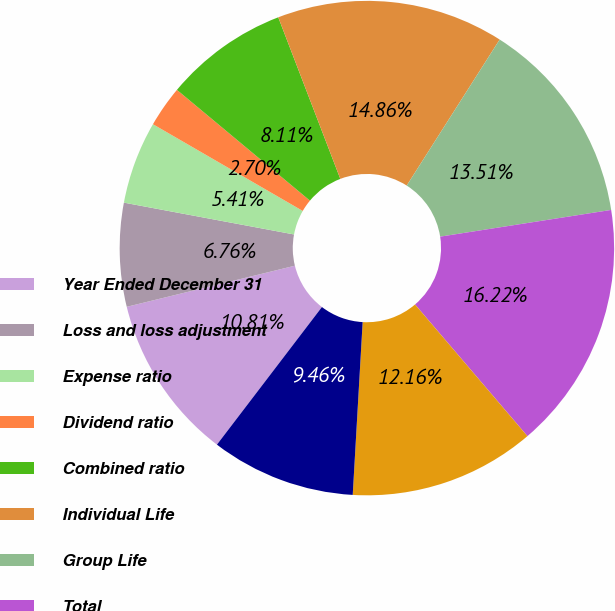<chart> <loc_0><loc_0><loc_500><loc_500><pie_chart><fcel>Year Ended December 31<fcel>Loss and loss adjustment<fcel>Expense ratio<fcel>Dividend ratio<fcel>Combined ratio<fcel>Individual Life<fcel>Group Life<fcel>Total<fcel>Property and casualty<fcel>Life and group companies'<nl><fcel>10.81%<fcel>6.76%<fcel>5.41%<fcel>2.7%<fcel>8.11%<fcel>14.86%<fcel>13.51%<fcel>16.22%<fcel>12.16%<fcel>9.46%<nl></chart> 